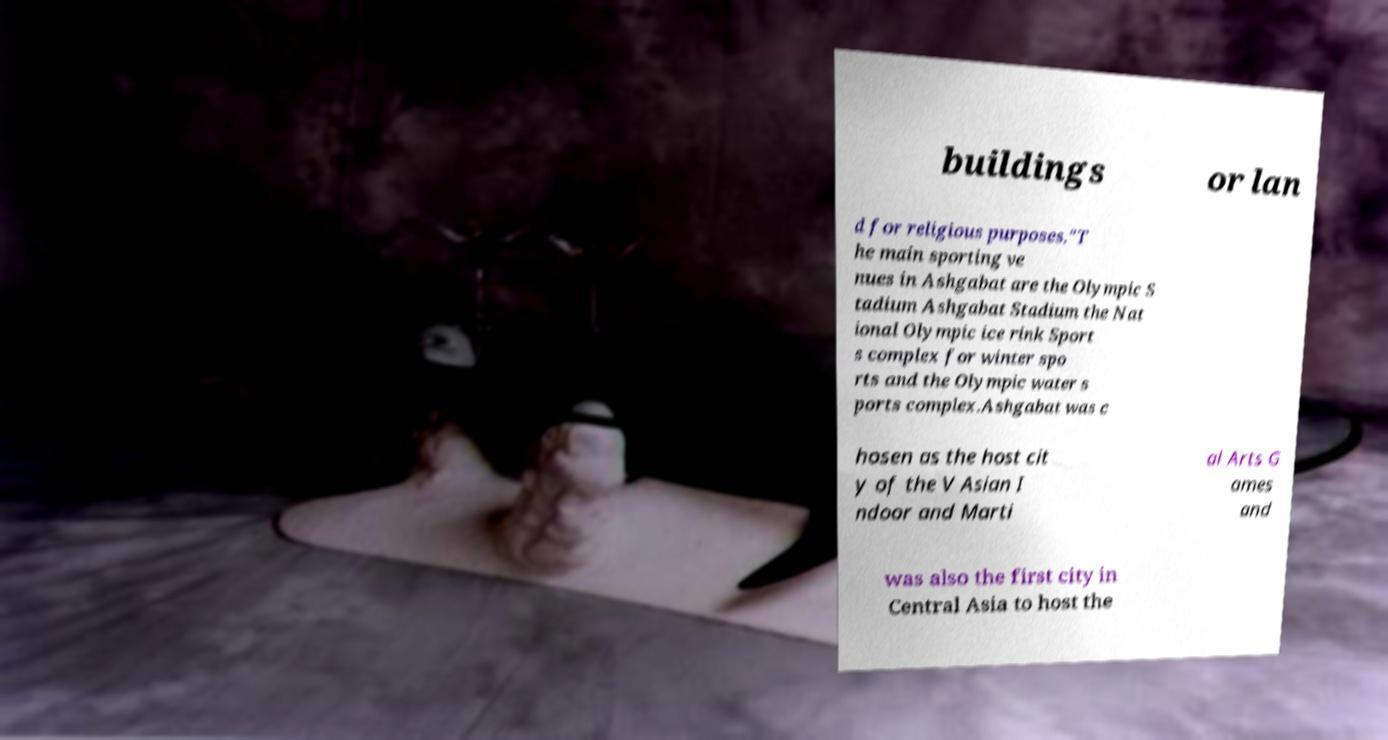Could you assist in decoding the text presented in this image and type it out clearly? buildings or lan d for religious purposes."T he main sporting ve nues in Ashgabat are the Olympic S tadium Ashgabat Stadium the Nat ional Olympic ice rink Sport s complex for winter spo rts and the Olympic water s ports complex.Ashgabat was c hosen as the host cit y of the V Asian I ndoor and Marti al Arts G ames and was also the first city in Central Asia to host the 